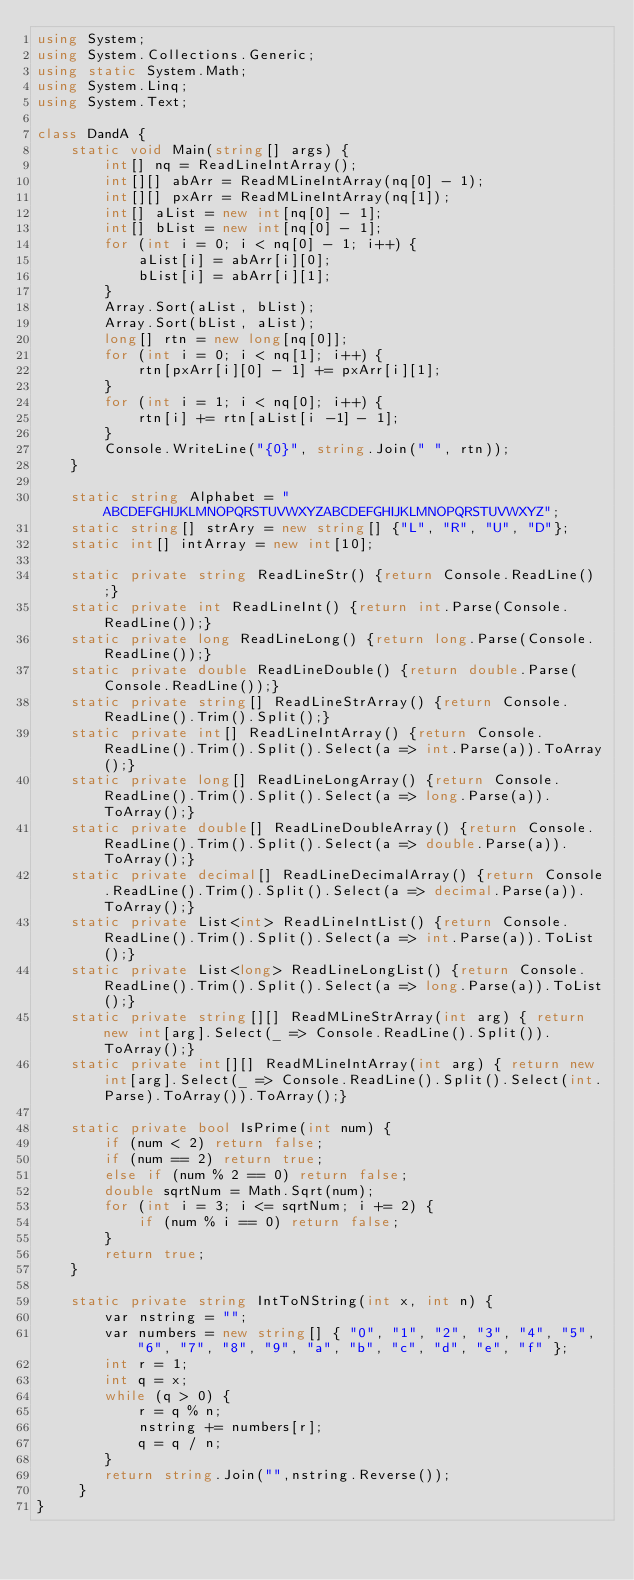<code> <loc_0><loc_0><loc_500><loc_500><_C#_>using System;
using System.Collections.Generic;
using static System.Math;
using System.Linq;
using System.Text;
 
class DandA {
    static void Main(string[] args) {
        int[] nq = ReadLineIntArray();
        int[][] abArr = ReadMLineIntArray(nq[0] - 1);
        int[][] pxArr = ReadMLineIntArray(nq[1]);
        int[] aList = new int[nq[0] - 1];
        int[] bList = new int[nq[0] - 1];
        for (int i = 0; i < nq[0] - 1; i++) {
            aList[i] = abArr[i][0];
            bList[i] = abArr[i][1];
        }
        Array.Sort(aList, bList);
        Array.Sort(bList, aList);
        long[] rtn = new long[nq[0]];
        for (int i = 0; i < nq[1]; i++) {
            rtn[pxArr[i][0] - 1] += pxArr[i][1];
        }
        for (int i = 1; i < nq[0]; i++) {
            rtn[i] += rtn[aList[i -1] - 1];
        }
        Console.WriteLine("{0}", string.Join(" ", rtn));
    }
 
    static string Alphabet = "ABCDEFGHIJKLMNOPQRSTUVWXYZABCDEFGHIJKLMNOPQRSTUVWXYZ";
    static string[] strAry = new string[] {"L", "R", "U", "D"};
    static int[] intArray = new int[10];
  
    static private string ReadLineStr() {return Console.ReadLine();}
    static private int ReadLineInt() {return int.Parse(Console.ReadLine());}
    static private long ReadLineLong() {return long.Parse(Console.ReadLine());}
    static private double ReadLineDouble() {return double.Parse(Console.ReadLine());}
    static private string[] ReadLineStrArray() {return Console.ReadLine().Trim().Split();}
    static private int[] ReadLineIntArray() {return Console.ReadLine().Trim().Split().Select(a => int.Parse(a)).ToArray();}
    static private long[] ReadLineLongArray() {return Console.ReadLine().Trim().Split().Select(a => long.Parse(a)).ToArray();}
    static private double[] ReadLineDoubleArray() {return Console.ReadLine().Trim().Split().Select(a => double.Parse(a)).ToArray();}
    static private decimal[] ReadLineDecimalArray() {return Console.ReadLine().Trim().Split().Select(a => decimal.Parse(a)).ToArray();}
    static private List<int> ReadLineIntList() {return Console.ReadLine().Trim().Split().Select(a => int.Parse(a)).ToList();}
    static private List<long> ReadLineLongList() {return Console.ReadLine().Trim().Split().Select(a => long.Parse(a)).ToList();}
    static private string[][] ReadMLineStrArray(int arg) { return new int[arg].Select(_ => Console.ReadLine().Split()).ToArray();}
    static private int[][] ReadMLineIntArray(int arg) { return new int[arg].Select(_ => Console.ReadLine().Split().Select(int.Parse).ToArray()).ToArray();}
 
    static private bool IsPrime(int num) {
        if (num < 2) return false;
        if (num == 2) return true;
        else if (num % 2 == 0) return false;
        double sqrtNum = Math.Sqrt(num);
        for (int i = 3; i <= sqrtNum; i += 2) {
            if (num % i == 0) return false;
        }
        return true;
    }
  
    static private string IntToNString(int x, int n) {
        var nstring = "";
        var numbers = new string[] { "0", "1", "2", "3", "4", "5", "6", "7", "8", "9", "a", "b", "c", "d", "e", "f" };
        int r = 1;
        int q = x;
        while (q > 0) {
            r = q % n;
            nstring += numbers[r];
            q = q / n;
        }
        return string.Join("",nstring.Reverse());
     }
}</code> 